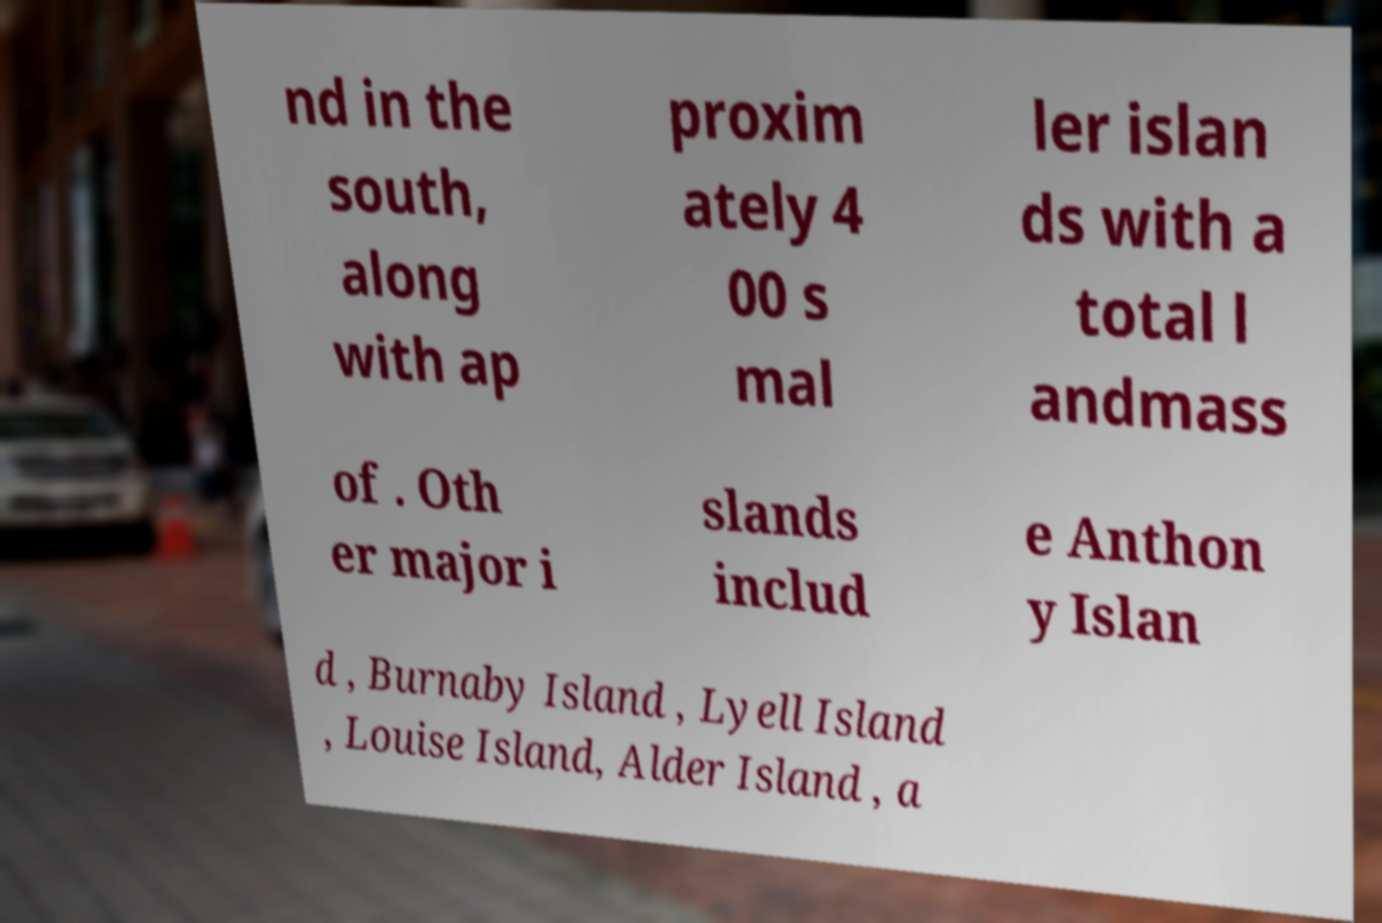For documentation purposes, I need the text within this image transcribed. Could you provide that? nd in the south, along with ap proxim ately 4 00 s mal ler islan ds with a total l andmass of . Oth er major i slands includ e Anthon y Islan d , Burnaby Island , Lyell Island , Louise Island, Alder Island , a 